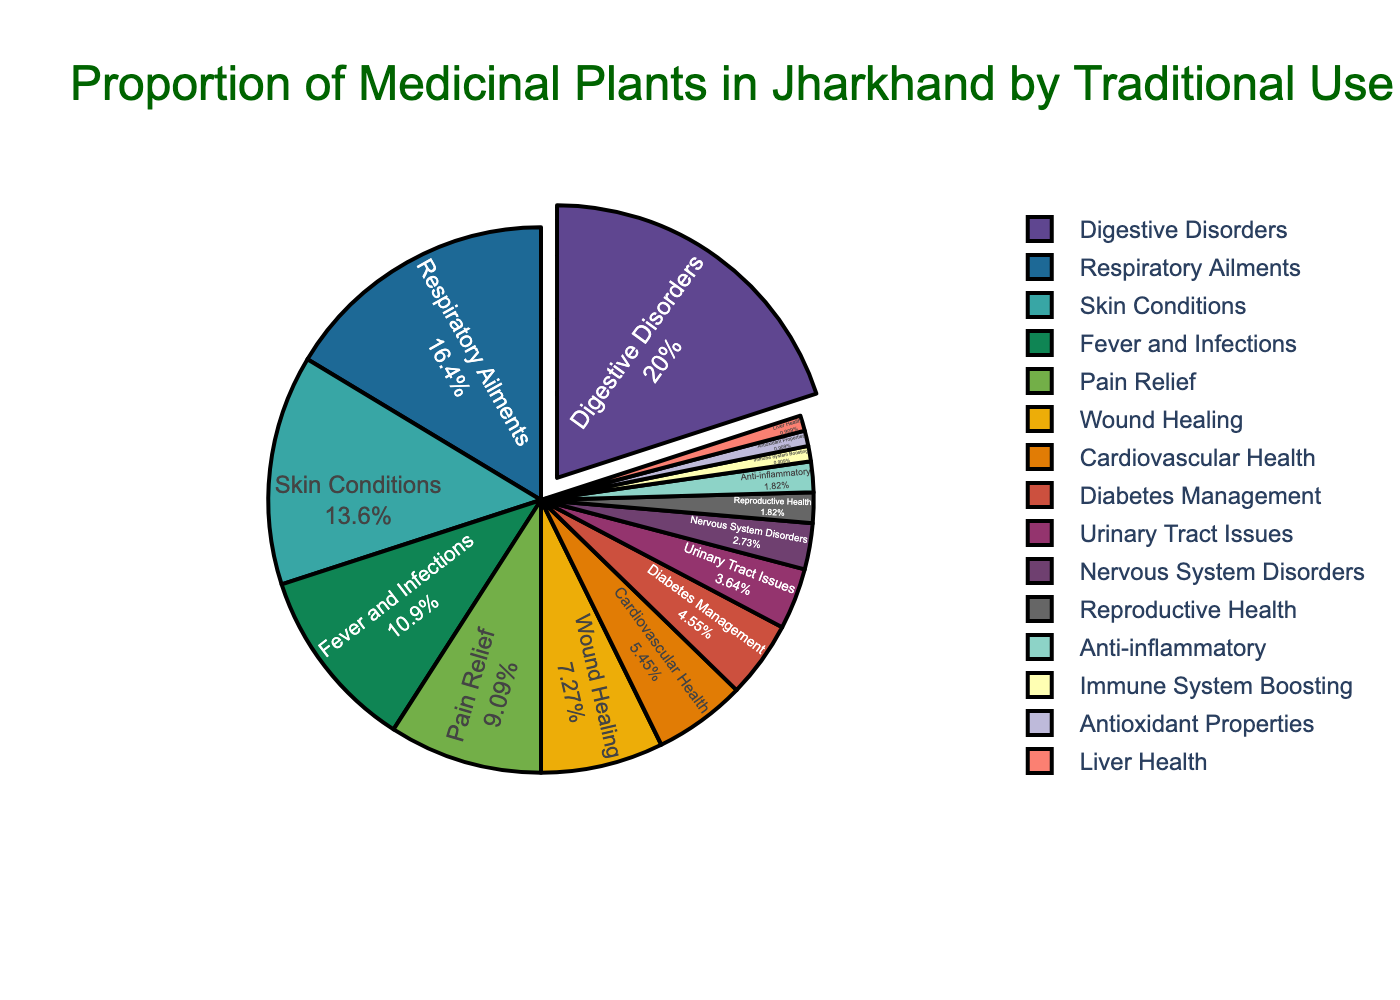what traditional use occupies the largest proportion of the pie chart? The slice that occupies the largest proportion of the pie chart is visibly the largest. Referring to the chart, the largest slice corresponds to Digestive Disorders.
Answer: Digestive Disorders compare the proportions of plants used for respiratory ailments and immune system boosting. To answer this, identify the slices labeled Respiratory Ailments and Immune System Boosting. Respiratory Ailments has 18%, while Immune System Boosting has 1%.
Answer: Respiratory Ailments > Immune System Boosting what proportion of the pie chart is dedicated to reproductive health? Identify the slice labeled Reproductive Health. Referring to the chart, Reproductive Health makes up 2% of the pie chart.
Answer: 2% how much larger is the proportion for skin conditions compared to antioxidants? Find the proportions for Skin Conditions (15%) and Antioxidant Properties (1%). Subtract the smaller from the larger: 15% - 1% = 14%.
Answer: 14% which traditional use categories combined form the smallest proportion? Sum up the smallest categories until other categories are exceeded. Combining Immune System Boosting (1%), Antioxidant Properties (1%), and Liver Health (1%) totals 3%. Categories like Nervous System Disorders (3%) alone are equivalent but not less than this sum.
Answer: Immune System Boosting, Antioxidant Properties, Liver Health which slice is given a visual highlight such as being pulled out from the pie? Visibly identify which slice is 'pulled out' or separated from the pie chart. The chart shows Digestive Disorders as the visually highlighted slice.
Answer: Digestive Disorders if we combine the proportions of plants used for cardiovascular and diabetes management, how would their combined proportion compare to the proportion for fever and infections? Sum the proportions for Cardiovascular Health (6%) and Diabetes Management (5%); that equals 11%. Compare this sum to Fever and Infections' proportion, which is 12%.
Answer: Less what do the colors of the traditional uses suggest about their distribution? Observing the color distribution, each traditional use has a distinct color reflecting its individual proportion, with no two segments appearing the same, emphasizing variety and diversity in medicinal uses.
Answer: Reflects variety 